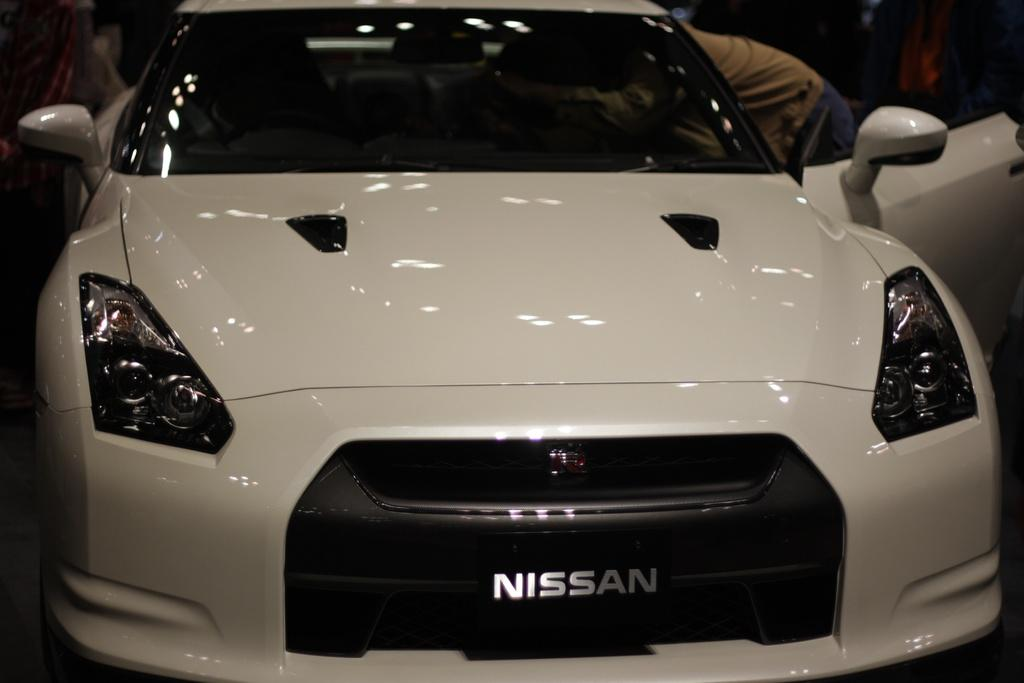What is the main subject of the image? There is a car in the image. Can you describe any actions or interactions happening in the image? A person is peeping into the car on the right side. How many ants can be seen crawling on the car in the image? There are no ants visible in the image. What color is the ladybug sitting on the car's hood? There is no ladybug present in the image. 